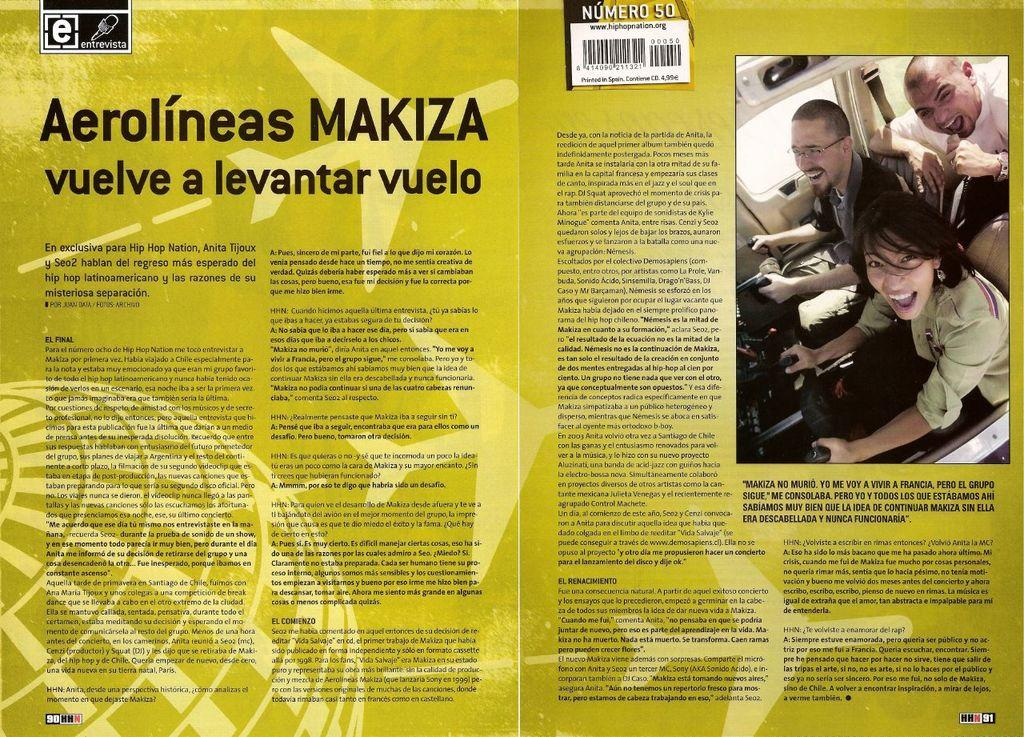What is the main subject of the image? The main subject of the image is a page of a book. What can be seen on the right side of the page? There is an image on the right side of the page. What is located at the top of the image? A bar code is present at the top of the image. What is written on the page? There is text written on the page. What type of cushion is visible in the image? There is no cushion present in the image. What meal is being prepared in the image? There is no meal preparation depicted in the image; it features a page of a book. 